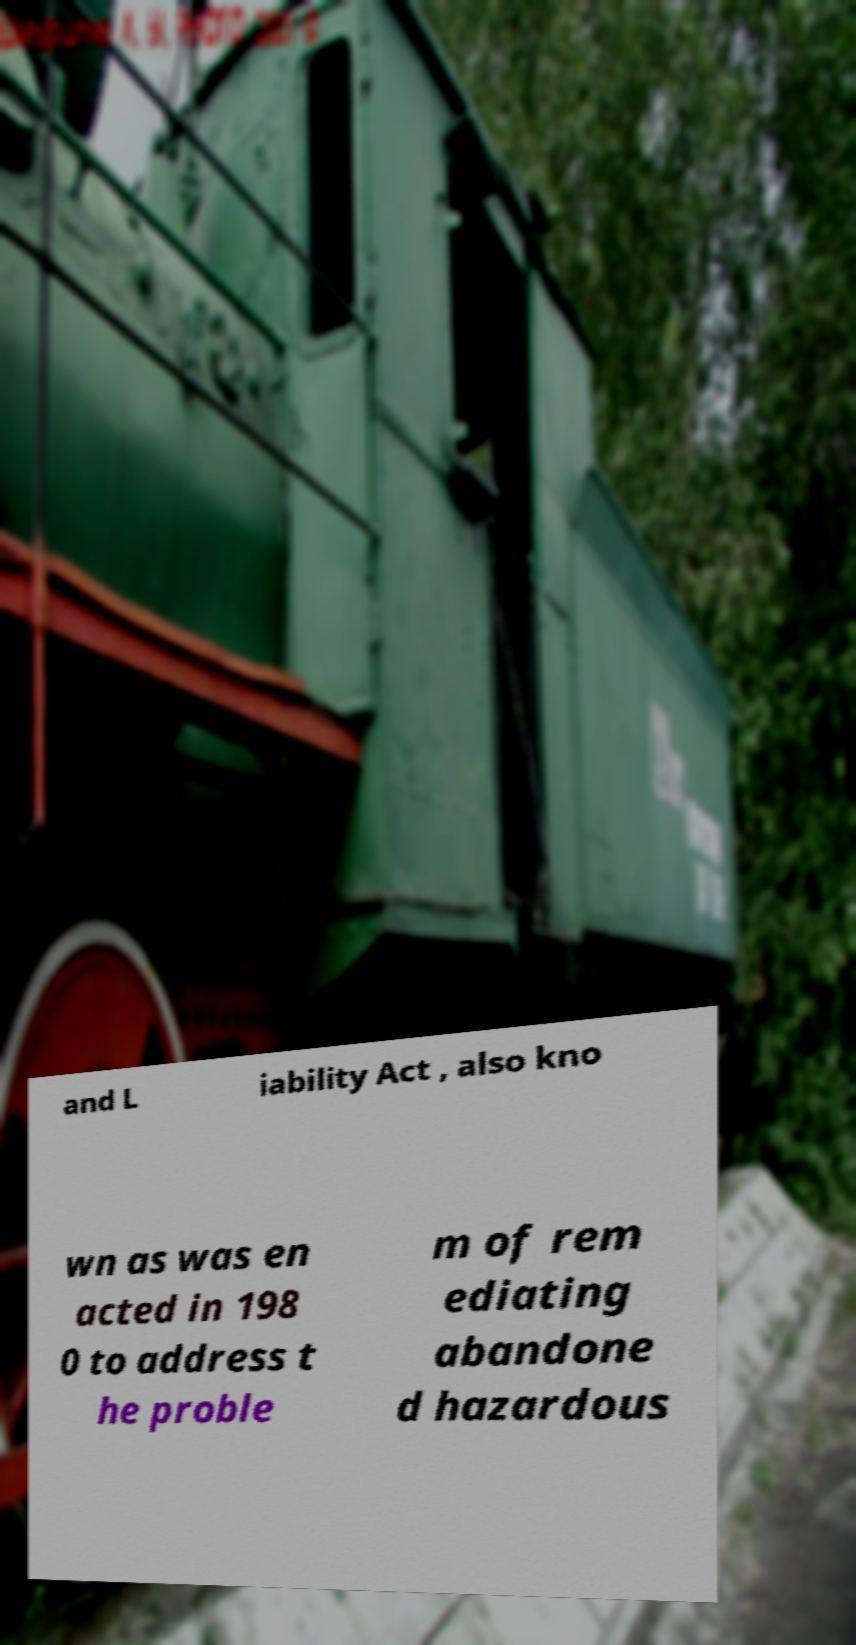Please read and relay the text visible in this image. What does it say? and L iability Act , also kno wn as was en acted in 198 0 to address t he proble m of rem ediating abandone d hazardous 